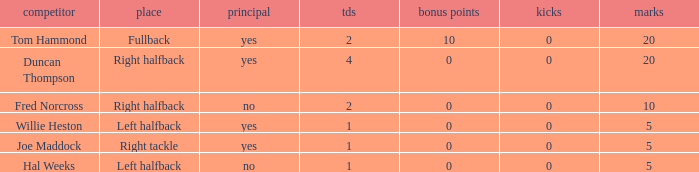What is the highest field goals when there were more than 1 touchdown and 0 extra points? 0.0. 